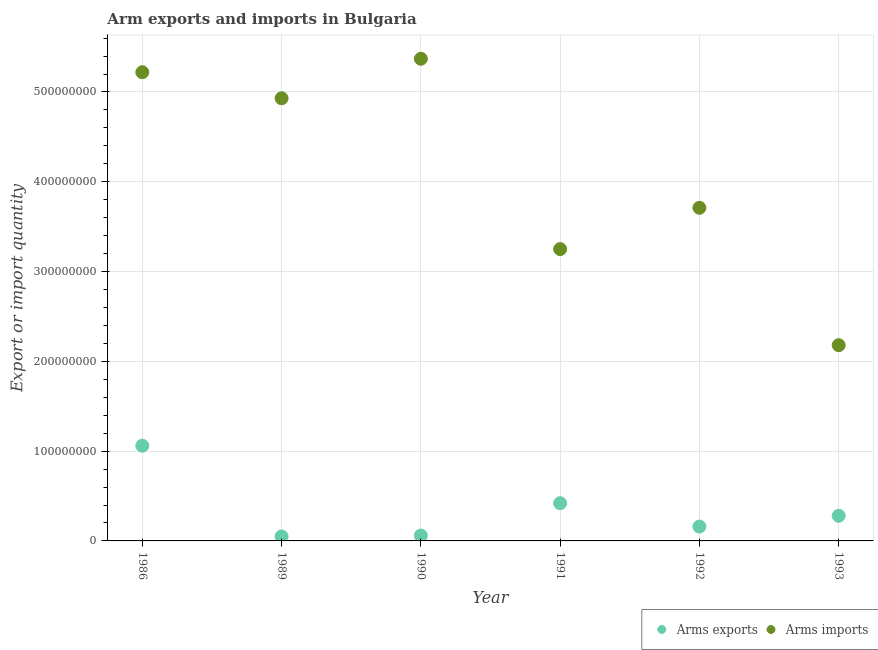How many different coloured dotlines are there?
Ensure brevity in your answer.  2. Is the number of dotlines equal to the number of legend labels?
Your response must be concise. Yes. What is the arms exports in 1993?
Offer a very short reply. 2.80e+07. Across all years, what is the maximum arms exports?
Your answer should be very brief. 1.06e+08. Across all years, what is the minimum arms exports?
Your answer should be very brief. 5.00e+06. What is the total arms exports in the graph?
Your response must be concise. 2.03e+08. What is the difference between the arms exports in 1986 and that in 1991?
Provide a short and direct response. 6.40e+07. What is the difference between the arms imports in 1990 and the arms exports in 1992?
Make the answer very short. 5.21e+08. What is the average arms exports per year?
Your answer should be very brief. 3.38e+07. In the year 1986, what is the difference between the arms imports and arms exports?
Your answer should be compact. 4.16e+08. What is the ratio of the arms imports in 1986 to that in 1991?
Your response must be concise. 1.61. What is the difference between the highest and the second highest arms exports?
Your answer should be compact. 6.40e+07. What is the difference between the highest and the lowest arms exports?
Your answer should be compact. 1.01e+08. Is the sum of the arms imports in 1989 and 1990 greater than the maximum arms exports across all years?
Provide a succinct answer. Yes. Is the arms imports strictly less than the arms exports over the years?
Offer a very short reply. No. What is the difference between two consecutive major ticks on the Y-axis?
Ensure brevity in your answer.  1.00e+08. Are the values on the major ticks of Y-axis written in scientific E-notation?
Keep it short and to the point. No. Does the graph contain grids?
Give a very brief answer. Yes. How many legend labels are there?
Make the answer very short. 2. What is the title of the graph?
Make the answer very short. Arm exports and imports in Bulgaria. Does "Malaria" appear as one of the legend labels in the graph?
Offer a very short reply. No. What is the label or title of the Y-axis?
Provide a short and direct response. Export or import quantity. What is the Export or import quantity of Arms exports in 1986?
Give a very brief answer. 1.06e+08. What is the Export or import quantity of Arms imports in 1986?
Offer a terse response. 5.22e+08. What is the Export or import quantity in Arms imports in 1989?
Make the answer very short. 4.93e+08. What is the Export or import quantity of Arms exports in 1990?
Provide a succinct answer. 6.00e+06. What is the Export or import quantity of Arms imports in 1990?
Keep it short and to the point. 5.37e+08. What is the Export or import quantity in Arms exports in 1991?
Keep it short and to the point. 4.20e+07. What is the Export or import quantity of Arms imports in 1991?
Make the answer very short. 3.25e+08. What is the Export or import quantity in Arms exports in 1992?
Your answer should be very brief. 1.60e+07. What is the Export or import quantity in Arms imports in 1992?
Provide a short and direct response. 3.71e+08. What is the Export or import quantity in Arms exports in 1993?
Keep it short and to the point. 2.80e+07. What is the Export or import quantity in Arms imports in 1993?
Your answer should be compact. 2.18e+08. Across all years, what is the maximum Export or import quantity in Arms exports?
Your answer should be compact. 1.06e+08. Across all years, what is the maximum Export or import quantity of Arms imports?
Offer a terse response. 5.37e+08. Across all years, what is the minimum Export or import quantity in Arms imports?
Ensure brevity in your answer.  2.18e+08. What is the total Export or import quantity in Arms exports in the graph?
Your answer should be compact. 2.03e+08. What is the total Export or import quantity of Arms imports in the graph?
Keep it short and to the point. 2.47e+09. What is the difference between the Export or import quantity in Arms exports in 1986 and that in 1989?
Your response must be concise. 1.01e+08. What is the difference between the Export or import quantity in Arms imports in 1986 and that in 1989?
Ensure brevity in your answer.  2.90e+07. What is the difference between the Export or import quantity of Arms exports in 1986 and that in 1990?
Offer a terse response. 1.00e+08. What is the difference between the Export or import quantity of Arms imports in 1986 and that in 1990?
Ensure brevity in your answer.  -1.50e+07. What is the difference between the Export or import quantity in Arms exports in 1986 and that in 1991?
Make the answer very short. 6.40e+07. What is the difference between the Export or import quantity in Arms imports in 1986 and that in 1991?
Your response must be concise. 1.97e+08. What is the difference between the Export or import quantity in Arms exports in 1986 and that in 1992?
Make the answer very short. 9.00e+07. What is the difference between the Export or import quantity of Arms imports in 1986 and that in 1992?
Your response must be concise. 1.51e+08. What is the difference between the Export or import quantity of Arms exports in 1986 and that in 1993?
Give a very brief answer. 7.80e+07. What is the difference between the Export or import quantity in Arms imports in 1986 and that in 1993?
Your answer should be compact. 3.04e+08. What is the difference between the Export or import quantity of Arms imports in 1989 and that in 1990?
Ensure brevity in your answer.  -4.40e+07. What is the difference between the Export or import quantity of Arms exports in 1989 and that in 1991?
Your response must be concise. -3.70e+07. What is the difference between the Export or import quantity of Arms imports in 1989 and that in 1991?
Provide a succinct answer. 1.68e+08. What is the difference between the Export or import quantity of Arms exports in 1989 and that in 1992?
Keep it short and to the point. -1.10e+07. What is the difference between the Export or import quantity of Arms imports in 1989 and that in 1992?
Your answer should be compact. 1.22e+08. What is the difference between the Export or import quantity of Arms exports in 1989 and that in 1993?
Your answer should be compact. -2.30e+07. What is the difference between the Export or import quantity of Arms imports in 1989 and that in 1993?
Make the answer very short. 2.75e+08. What is the difference between the Export or import quantity in Arms exports in 1990 and that in 1991?
Your response must be concise. -3.60e+07. What is the difference between the Export or import quantity of Arms imports in 1990 and that in 1991?
Your answer should be very brief. 2.12e+08. What is the difference between the Export or import quantity of Arms exports in 1990 and that in 1992?
Your answer should be compact. -1.00e+07. What is the difference between the Export or import quantity in Arms imports in 1990 and that in 1992?
Keep it short and to the point. 1.66e+08. What is the difference between the Export or import quantity of Arms exports in 1990 and that in 1993?
Provide a succinct answer. -2.20e+07. What is the difference between the Export or import quantity of Arms imports in 1990 and that in 1993?
Provide a succinct answer. 3.19e+08. What is the difference between the Export or import quantity in Arms exports in 1991 and that in 1992?
Your answer should be compact. 2.60e+07. What is the difference between the Export or import quantity of Arms imports in 1991 and that in 1992?
Provide a succinct answer. -4.60e+07. What is the difference between the Export or import quantity of Arms exports in 1991 and that in 1993?
Keep it short and to the point. 1.40e+07. What is the difference between the Export or import quantity in Arms imports in 1991 and that in 1993?
Your answer should be very brief. 1.07e+08. What is the difference between the Export or import quantity in Arms exports in 1992 and that in 1993?
Offer a very short reply. -1.20e+07. What is the difference between the Export or import quantity of Arms imports in 1992 and that in 1993?
Give a very brief answer. 1.53e+08. What is the difference between the Export or import quantity in Arms exports in 1986 and the Export or import quantity in Arms imports in 1989?
Your response must be concise. -3.87e+08. What is the difference between the Export or import quantity of Arms exports in 1986 and the Export or import quantity of Arms imports in 1990?
Your response must be concise. -4.31e+08. What is the difference between the Export or import quantity of Arms exports in 1986 and the Export or import quantity of Arms imports in 1991?
Provide a short and direct response. -2.19e+08. What is the difference between the Export or import quantity of Arms exports in 1986 and the Export or import quantity of Arms imports in 1992?
Offer a terse response. -2.65e+08. What is the difference between the Export or import quantity of Arms exports in 1986 and the Export or import quantity of Arms imports in 1993?
Keep it short and to the point. -1.12e+08. What is the difference between the Export or import quantity of Arms exports in 1989 and the Export or import quantity of Arms imports in 1990?
Keep it short and to the point. -5.32e+08. What is the difference between the Export or import quantity of Arms exports in 1989 and the Export or import quantity of Arms imports in 1991?
Provide a short and direct response. -3.20e+08. What is the difference between the Export or import quantity of Arms exports in 1989 and the Export or import quantity of Arms imports in 1992?
Offer a very short reply. -3.66e+08. What is the difference between the Export or import quantity of Arms exports in 1989 and the Export or import quantity of Arms imports in 1993?
Your answer should be very brief. -2.13e+08. What is the difference between the Export or import quantity in Arms exports in 1990 and the Export or import quantity in Arms imports in 1991?
Keep it short and to the point. -3.19e+08. What is the difference between the Export or import quantity in Arms exports in 1990 and the Export or import quantity in Arms imports in 1992?
Provide a short and direct response. -3.65e+08. What is the difference between the Export or import quantity in Arms exports in 1990 and the Export or import quantity in Arms imports in 1993?
Provide a succinct answer. -2.12e+08. What is the difference between the Export or import quantity in Arms exports in 1991 and the Export or import quantity in Arms imports in 1992?
Offer a terse response. -3.29e+08. What is the difference between the Export or import quantity in Arms exports in 1991 and the Export or import quantity in Arms imports in 1993?
Offer a very short reply. -1.76e+08. What is the difference between the Export or import quantity in Arms exports in 1992 and the Export or import quantity in Arms imports in 1993?
Give a very brief answer. -2.02e+08. What is the average Export or import quantity in Arms exports per year?
Offer a very short reply. 3.38e+07. What is the average Export or import quantity of Arms imports per year?
Your answer should be compact. 4.11e+08. In the year 1986, what is the difference between the Export or import quantity of Arms exports and Export or import quantity of Arms imports?
Offer a terse response. -4.16e+08. In the year 1989, what is the difference between the Export or import quantity of Arms exports and Export or import quantity of Arms imports?
Your answer should be very brief. -4.88e+08. In the year 1990, what is the difference between the Export or import quantity in Arms exports and Export or import quantity in Arms imports?
Your answer should be very brief. -5.31e+08. In the year 1991, what is the difference between the Export or import quantity of Arms exports and Export or import quantity of Arms imports?
Your answer should be compact. -2.83e+08. In the year 1992, what is the difference between the Export or import quantity of Arms exports and Export or import quantity of Arms imports?
Make the answer very short. -3.55e+08. In the year 1993, what is the difference between the Export or import quantity of Arms exports and Export or import quantity of Arms imports?
Offer a very short reply. -1.90e+08. What is the ratio of the Export or import quantity of Arms exports in 1986 to that in 1989?
Keep it short and to the point. 21.2. What is the ratio of the Export or import quantity in Arms imports in 1986 to that in 1989?
Your answer should be compact. 1.06. What is the ratio of the Export or import quantity of Arms exports in 1986 to that in 1990?
Provide a succinct answer. 17.67. What is the ratio of the Export or import quantity of Arms imports in 1986 to that in 1990?
Keep it short and to the point. 0.97. What is the ratio of the Export or import quantity in Arms exports in 1986 to that in 1991?
Your response must be concise. 2.52. What is the ratio of the Export or import quantity of Arms imports in 1986 to that in 1991?
Give a very brief answer. 1.61. What is the ratio of the Export or import quantity of Arms exports in 1986 to that in 1992?
Your answer should be compact. 6.62. What is the ratio of the Export or import quantity in Arms imports in 1986 to that in 1992?
Your response must be concise. 1.41. What is the ratio of the Export or import quantity in Arms exports in 1986 to that in 1993?
Provide a succinct answer. 3.79. What is the ratio of the Export or import quantity in Arms imports in 1986 to that in 1993?
Provide a succinct answer. 2.39. What is the ratio of the Export or import quantity in Arms imports in 1989 to that in 1990?
Offer a terse response. 0.92. What is the ratio of the Export or import quantity in Arms exports in 1989 to that in 1991?
Your answer should be very brief. 0.12. What is the ratio of the Export or import quantity in Arms imports in 1989 to that in 1991?
Offer a terse response. 1.52. What is the ratio of the Export or import quantity in Arms exports in 1989 to that in 1992?
Offer a terse response. 0.31. What is the ratio of the Export or import quantity in Arms imports in 1989 to that in 1992?
Ensure brevity in your answer.  1.33. What is the ratio of the Export or import quantity of Arms exports in 1989 to that in 1993?
Make the answer very short. 0.18. What is the ratio of the Export or import quantity in Arms imports in 1989 to that in 1993?
Your answer should be compact. 2.26. What is the ratio of the Export or import quantity in Arms exports in 1990 to that in 1991?
Offer a very short reply. 0.14. What is the ratio of the Export or import quantity in Arms imports in 1990 to that in 1991?
Provide a succinct answer. 1.65. What is the ratio of the Export or import quantity of Arms imports in 1990 to that in 1992?
Ensure brevity in your answer.  1.45. What is the ratio of the Export or import quantity in Arms exports in 1990 to that in 1993?
Your answer should be very brief. 0.21. What is the ratio of the Export or import quantity of Arms imports in 1990 to that in 1993?
Offer a very short reply. 2.46. What is the ratio of the Export or import quantity of Arms exports in 1991 to that in 1992?
Provide a succinct answer. 2.62. What is the ratio of the Export or import quantity of Arms imports in 1991 to that in 1992?
Keep it short and to the point. 0.88. What is the ratio of the Export or import quantity of Arms imports in 1991 to that in 1993?
Your answer should be compact. 1.49. What is the ratio of the Export or import quantity in Arms exports in 1992 to that in 1993?
Ensure brevity in your answer.  0.57. What is the ratio of the Export or import quantity of Arms imports in 1992 to that in 1993?
Your answer should be very brief. 1.7. What is the difference between the highest and the second highest Export or import quantity of Arms exports?
Your response must be concise. 6.40e+07. What is the difference between the highest and the second highest Export or import quantity of Arms imports?
Keep it short and to the point. 1.50e+07. What is the difference between the highest and the lowest Export or import quantity of Arms exports?
Offer a very short reply. 1.01e+08. What is the difference between the highest and the lowest Export or import quantity in Arms imports?
Your answer should be compact. 3.19e+08. 